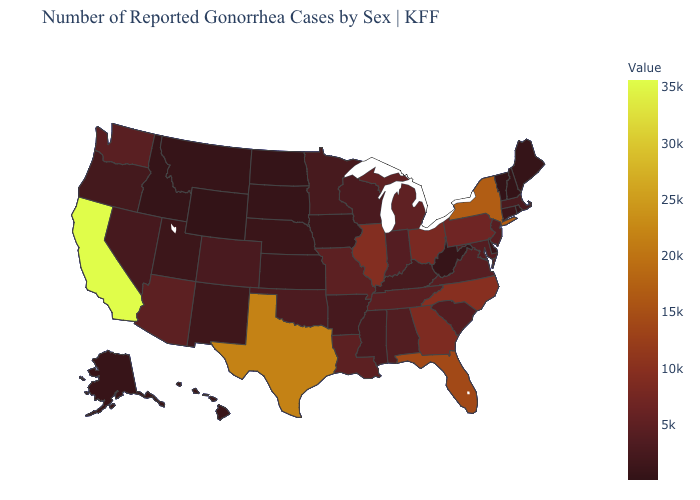Does South Carolina have a lower value than Texas?
Quick response, please. Yes. Does Vermont have the lowest value in the USA?
Concise answer only. Yes. Which states hav the highest value in the MidWest?
Write a very short answer. Illinois. Does West Virginia have the lowest value in the South?
Answer briefly. Yes. Among the states that border Minnesota , does Wisconsin have the highest value?
Short answer required. Yes. 